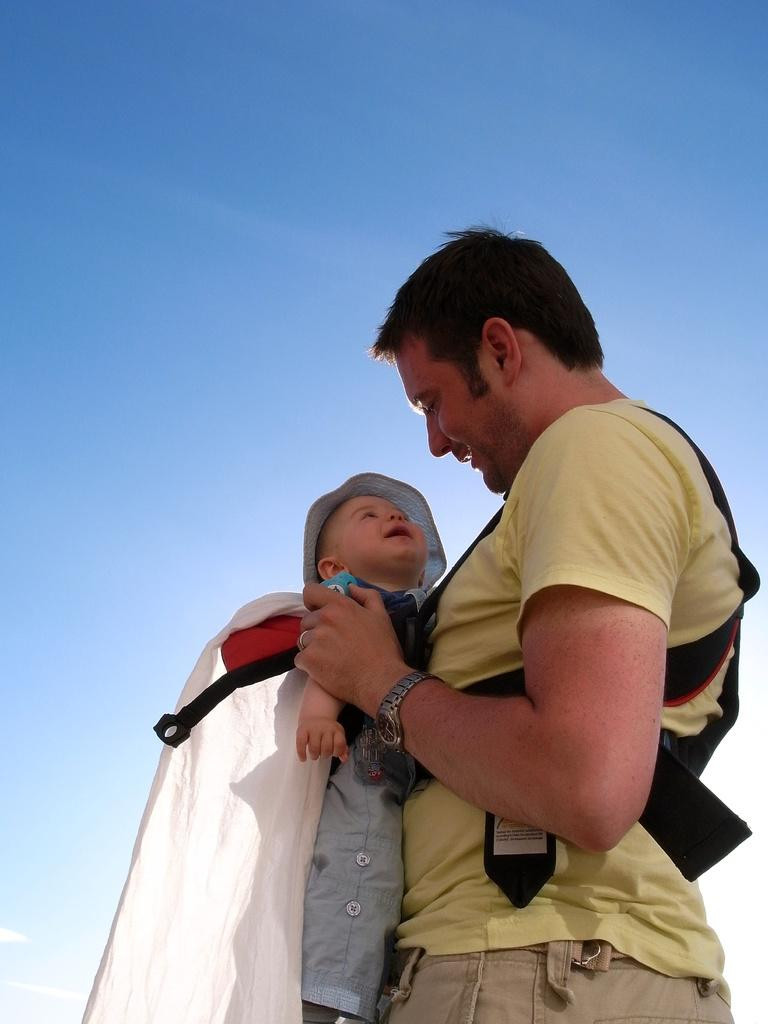Who is the main subject in the image? There is a man in the image. What is the man doing in the image? The man is holding a kid in his hands. What can be seen in the background of the image? The sky is visible in the background of the image. Is there a maid in the image helping the man hold the kid? There is no mention of a maid in the image, and the man is holding the kid without any assistance. 